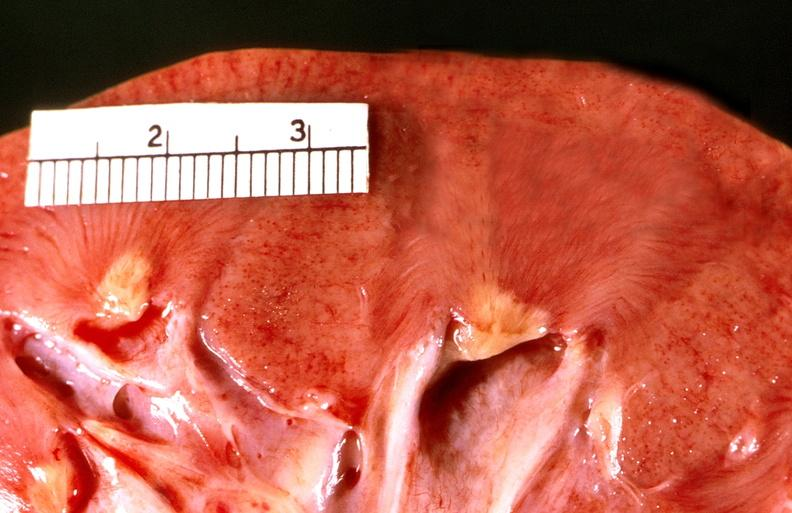does yo show renal papillary necrosis, diabetes mellitus dm?
Answer the question using a single word or phrase. No 